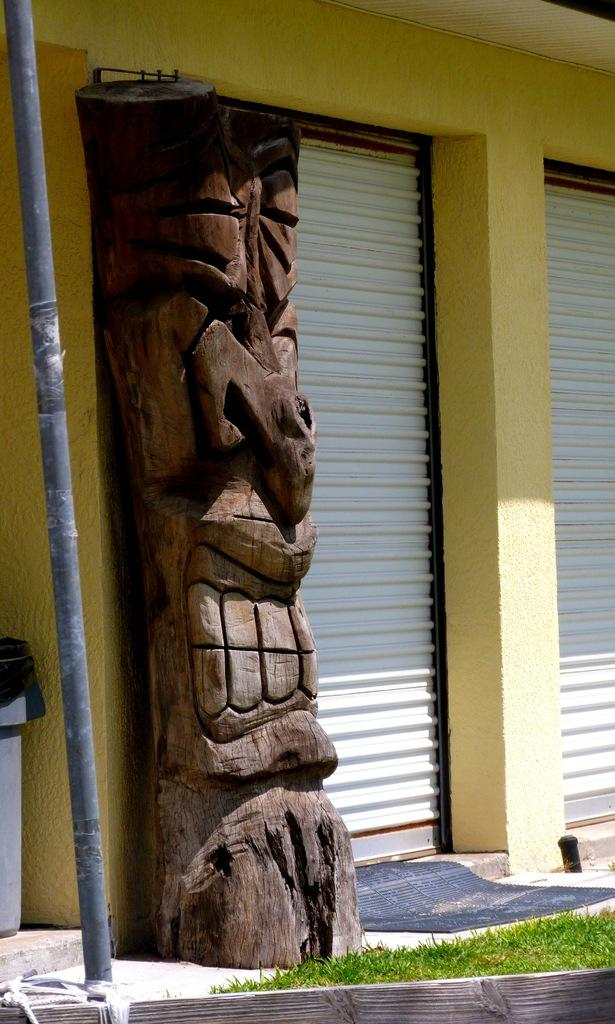What type of structure can be seen in the image? There is a wall in the image. What are the shutters attached to in the image? The shutters are attached to the wall in the image. What is the wooden pillar supporting in the image? The wooden pillar is supporting the wall in the image. What is used for waste disposal in the image? There is a dustbin in the image for waste disposal. What is the pole used for in the image? The purpose of the pole in the image is not clear, but it could be used for support or as a marker. What type of vegetation is visible in the image? There is grass visible in the image. How many children are playing with the glass in the image? There are no children or glass present in the image. What type of machine is used for cutting the grass in the image? There is no machine present in the image, and the grass is not being cut. 